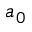<formula> <loc_0><loc_0><loc_500><loc_500>a _ { 0 }</formula> 